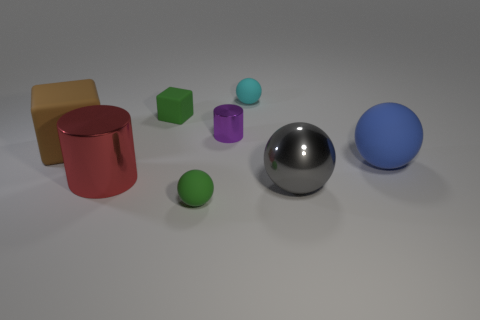The tiny metallic thing is what color?
Your response must be concise. Purple. Is the material of the big gray ball the same as the big red cylinder that is behind the gray ball?
Offer a very short reply. Yes. What number of objects are behind the blue matte object and to the left of the green cube?
Your answer should be very brief. 1. What shape is the brown thing that is the same size as the blue rubber sphere?
Offer a very short reply. Cube. There is a small matte ball that is in front of the large shiny thing that is to the right of the small cube; is there a green matte thing on the left side of it?
Offer a terse response. Yes. There is a large metal ball; is it the same color as the large matte object to the right of the gray metal ball?
Your response must be concise. No. What number of tiny rubber things are the same color as the big metal cylinder?
Offer a very short reply. 0. How big is the metal cylinder that is to the left of the green rubber thing that is in front of the big blue rubber object?
Your answer should be compact. Large. What number of things are small matte objects that are to the right of the green block or blue balls?
Provide a succinct answer. 3. Are there any purple metal objects that have the same size as the blue matte ball?
Provide a short and direct response. No. 